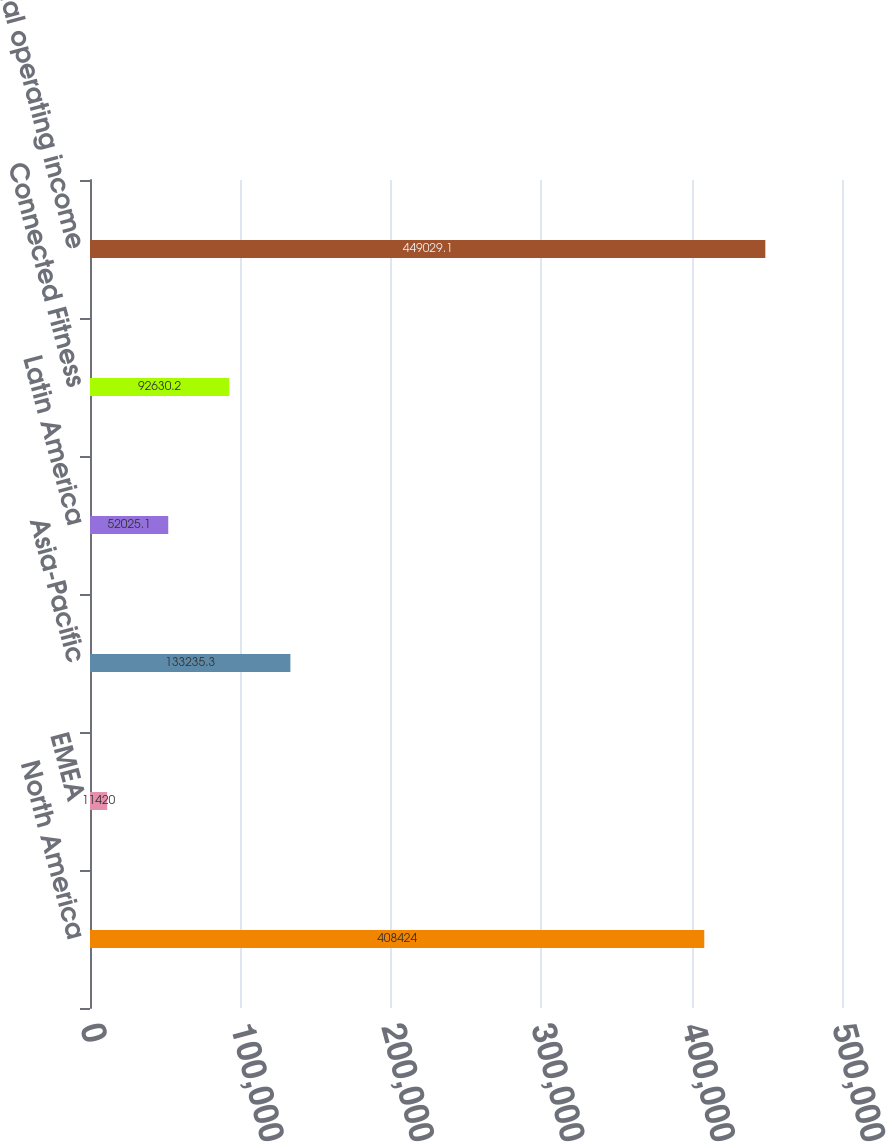Convert chart. <chart><loc_0><loc_0><loc_500><loc_500><bar_chart><fcel>North America<fcel>EMEA<fcel>Asia-Pacific<fcel>Latin America<fcel>Connected Fitness<fcel>Total operating income<nl><fcel>408424<fcel>11420<fcel>133235<fcel>52025.1<fcel>92630.2<fcel>449029<nl></chart> 